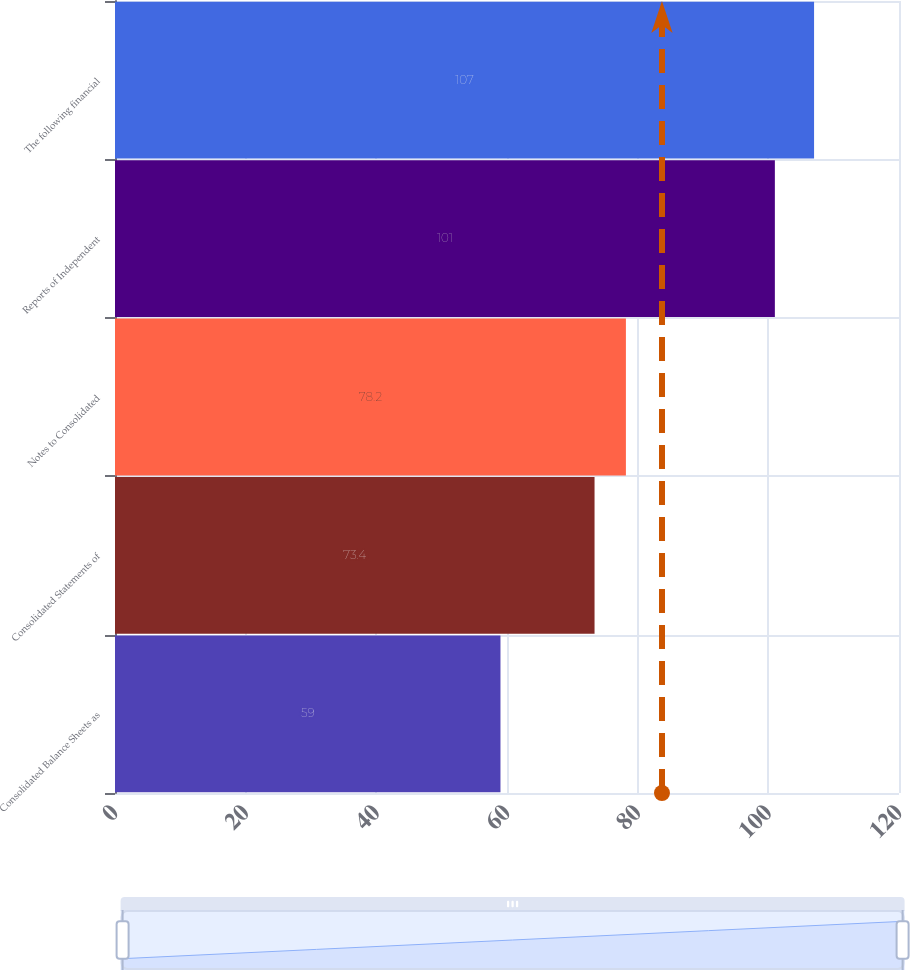Convert chart. <chart><loc_0><loc_0><loc_500><loc_500><bar_chart><fcel>Consolidated Balance Sheets as<fcel>Consolidated Statements of<fcel>Notes to Consolidated<fcel>Reports of Independent<fcel>The following financial<nl><fcel>59<fcel>73.4<fcel>78.2<fcel>101<fcel>107<nl></chart> 